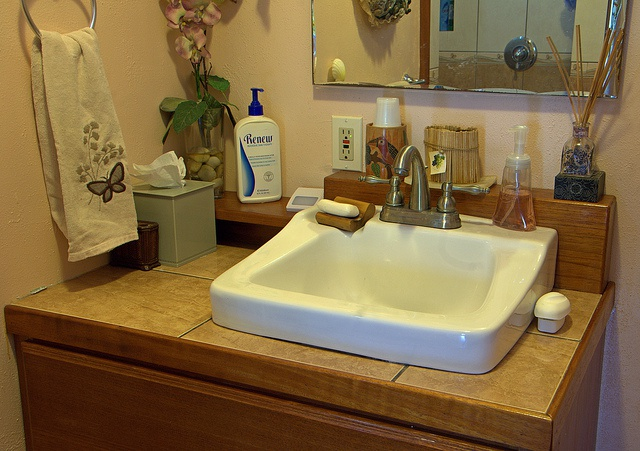Describe the objects in this image and their specific colors. I can see sink in tan, khaki, and darkgray tones, potted plant in tan, olive, black, maroon, and darkgreen tones, bottle in tan, navy, and gray tones, bottle in tan, maroon, and gray tones, and vase in tan, olive, maroon, and black tones in this image. 